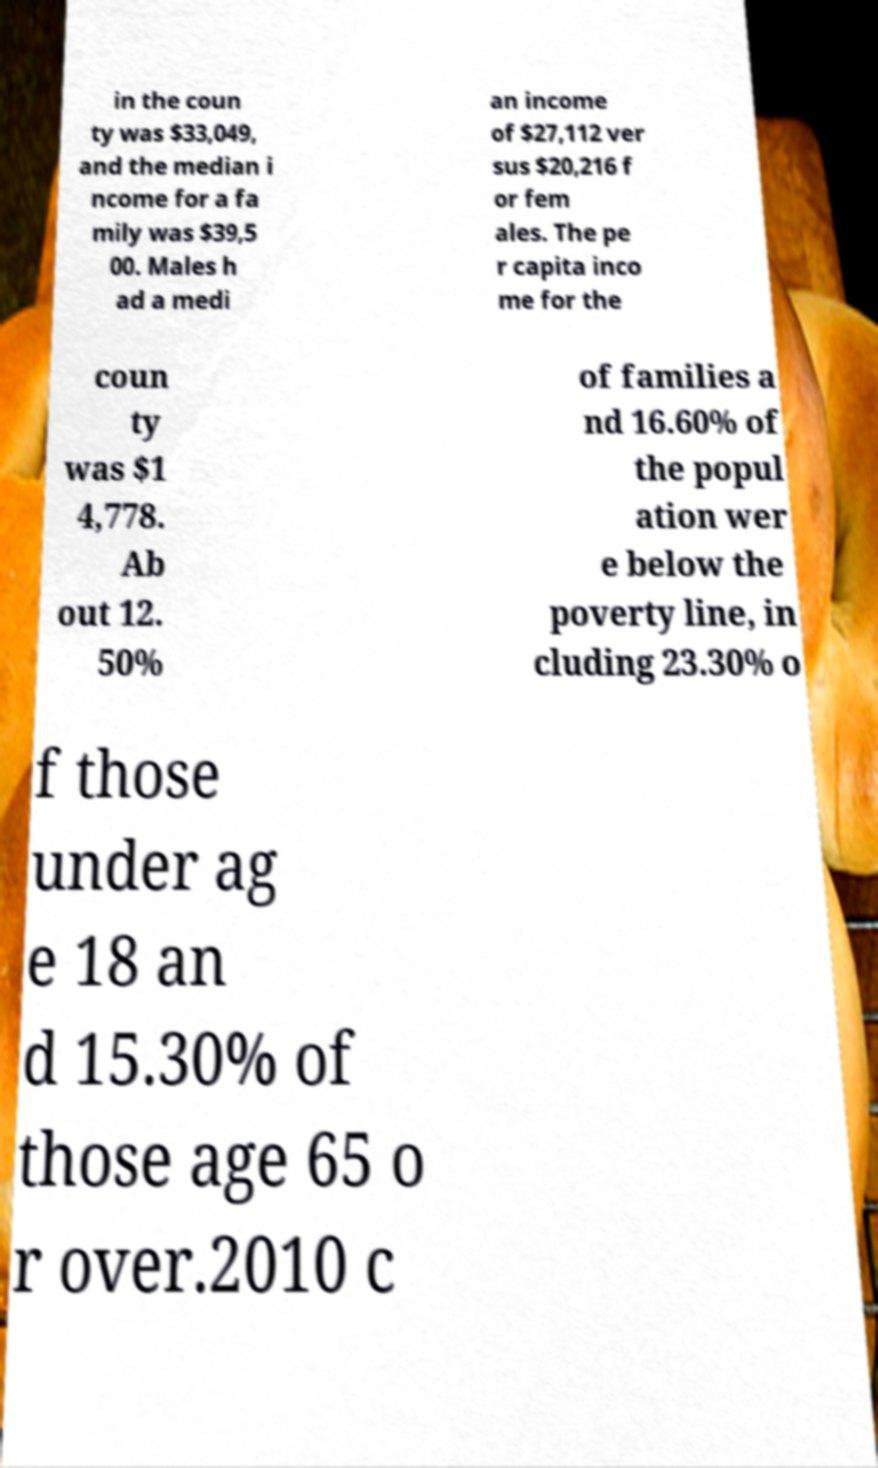What messages or text are displayed in this image? I need them in a readable, typed format. in the coun ty was $33,049, and the median i ncome for a fa mily was $39,5 00. Males h ad a medi an income of $27,112 ver sus $20,216 f or fem ales. The pe r capita inco me for the coun ty was $1 4,778. Ab out 12. 50% of families a nd 16.60% of the popul ation wer e below the poverty line, in cluding 23.30% o f those under ag e 18 an d 15.30% of those age 65 o r over.2010 c 